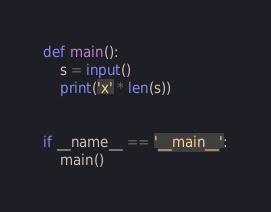<code> <loc_0><loc_0><loc_500><loc_500><_Python_>def main():
    s = input()
    print('x' * len(s))


if __name__ == '__main__':
    main()
</code> 